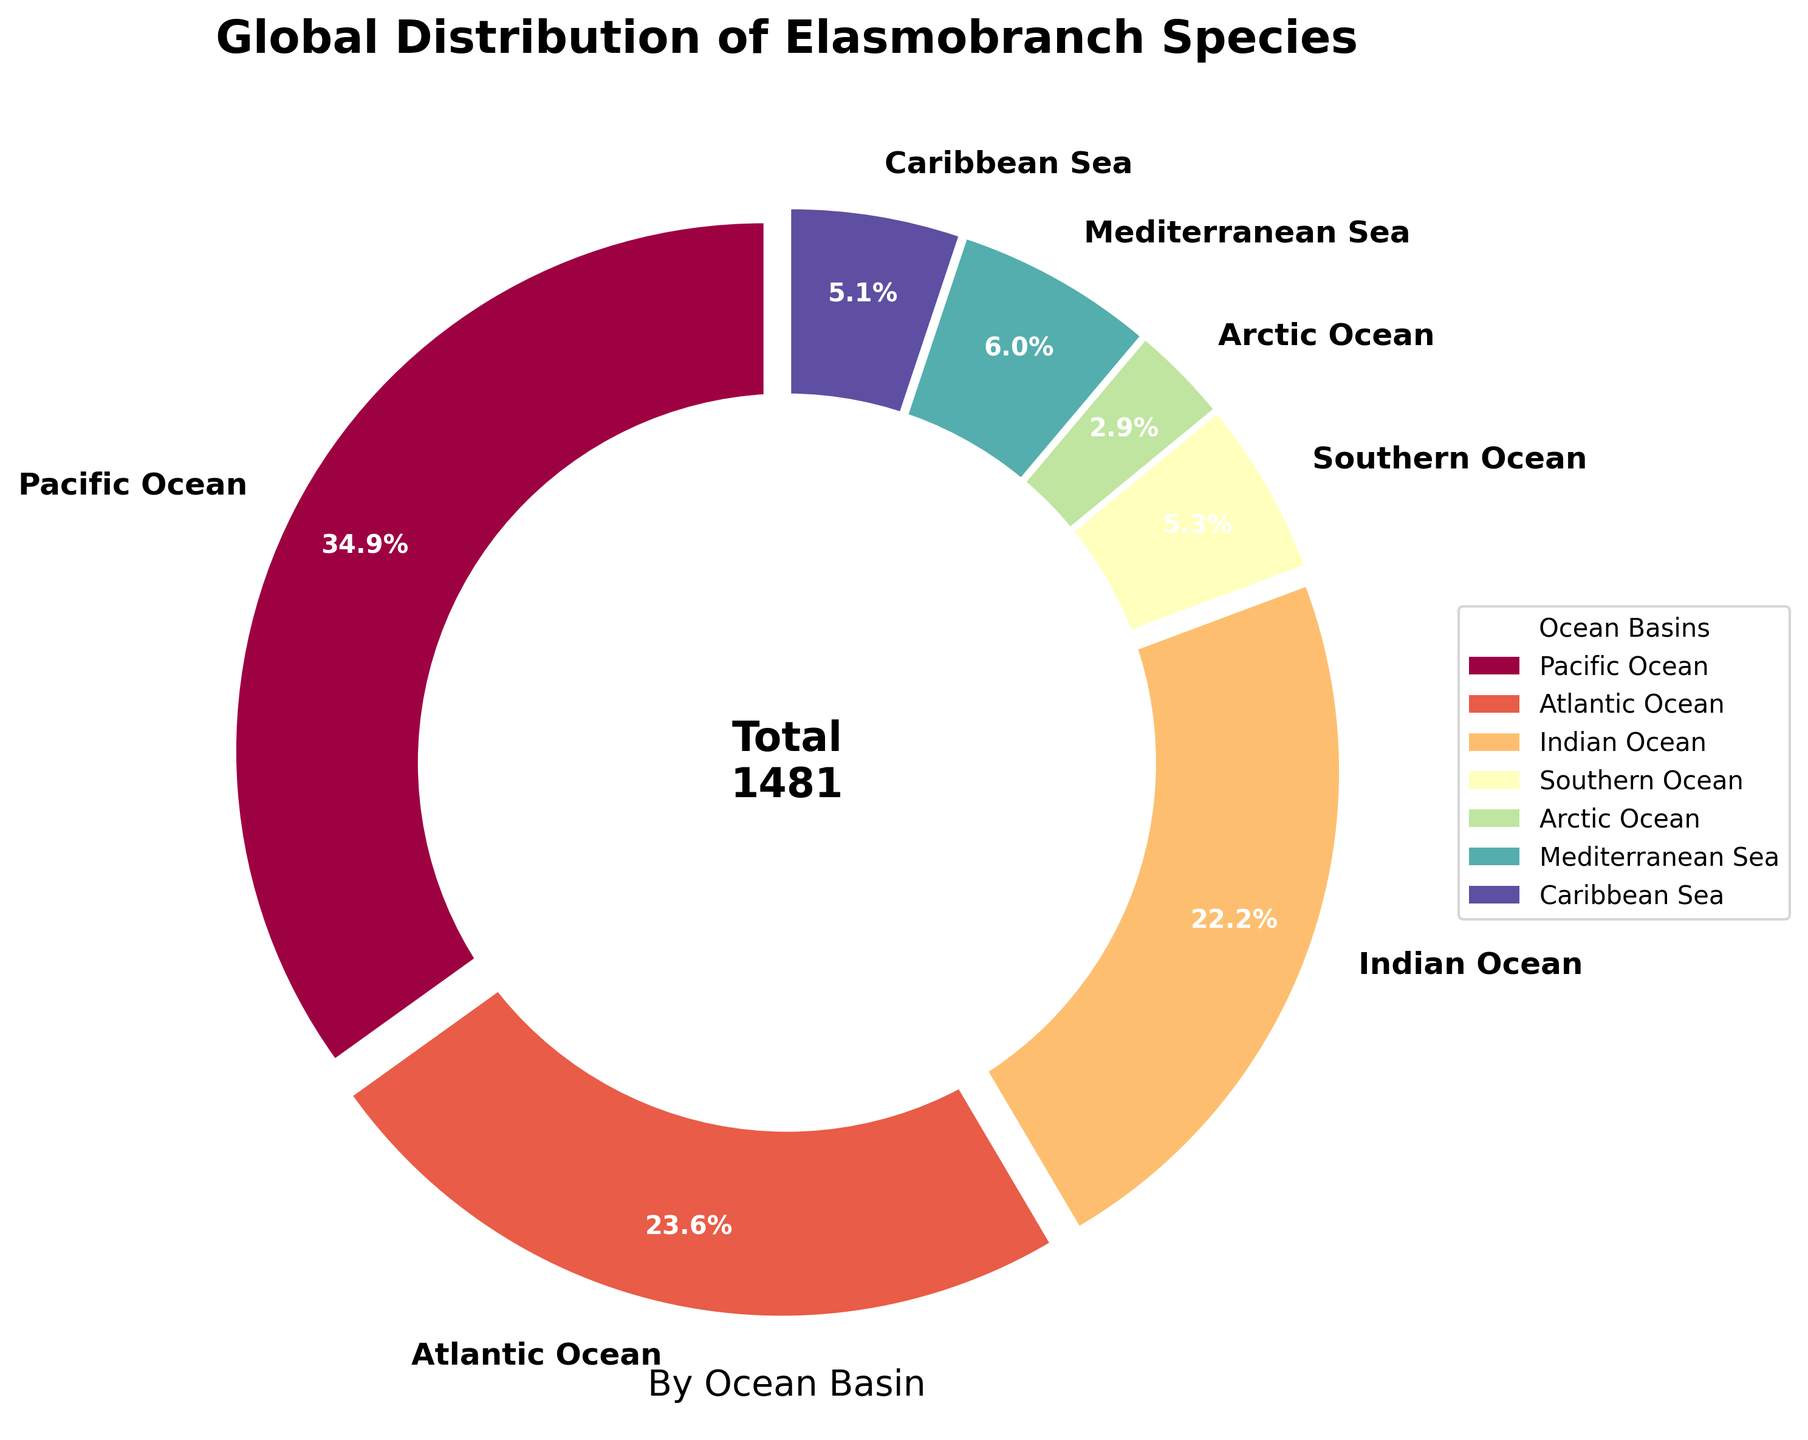What proportion of elasmobranch species are found in the Pacific Ocean? The figure indicates the portion sizes of a pie chart and includes the actual percentage for each segment. By visually identifying the segment labeled "Pacific Ocean" and reading its associated percentage, which is 41.5%, we can determine the proportion.
Answer: 41.5% Which ocean basin has the second-highest number of elasmobranch species? First, identify the ocean basin with the most elasmobranch species, which should have the largest pie chart segment. The Pacific Ocean has the most (41.5%). Next, look for the second largest segment, which corresponds to the Atlantic Ocean with 28.0%.
Answer: Atlantic Ocean How many more elasmobranch species are there in the Pacific Ocean compared to the Southern Ocean? Find the values for the Pacific Ocean (517 species) and the Southern Ocean (78 species). Subtract the number of species in the Southern Ocean from the Pacific Ocean (517 - 78 = 439).
Answer: 439 What percentage of elasmobranch species are found in the Atlantic, Indian, and Mediterranean combined? Add the number of species from the Atlantic (349), Indian (329), and Mediterranean (89) Oceans first, that is, 349 + 329 + 89 = 767. Then, find the total number of species, which is 517 + 349 + 329 + 78 + 43 + 89 + 76 = 1481. Calculate the combined percentage as (767 / 1481) * 100 = 51.8%.
Answer: 51.8% Which ocean basin has the smallest percentage of elasmobranch species, and what is this percentage? Identify the smallest segment in the pie chart, which is labeled "Arctic Ocean." Check the percentage displayed, which is 2.9%.
Answer: Arctic Ocean, 2.9% How does the number of species in the Caribbean Sea compare to the Southern Ocean? The Caribbean Sea has 76 species and the Southern Ocean has 78 species. By comparing these numbers, we see that the Caribbean Sea has slightly fewer species (76 < 78).
Answer: Southern Ocean has more species by 2 If you combine the elasmobranch species from the Arctic and Caribbean Seas, does this total surpass the Mediterranean Sea? Add the number of species from the Arctic (43) and Caribbean (76) Seas: 43 + 76 = 119. Compare this to the Mediterranean Sea, which has 89 species. Since 119 > 89, the combined total surpasses the Mediterranean Sea.
Answer: Yes What is the visual characteristic of the pie chart that indicates the Pacific Ocean segment? The visual characteristics include the size of the segment (the largest), its placement starting at the top of the chart, and its specific color within the color scheme used in the chart.
Answer: Largest segment, top placement Which three ocean basins together make up approximately half of the total elasmobranch species population? Examine the pie chart and identify the three largest segments: Pacific (41.5%), Atlantic (23.6%), and Indian (22.2%) Oceans. Together they make up approximately 41.5 + 23.6 + 22.2 = 87.3%. To get three basins that are around 50%, consider two largest segments and an additional segment that accumulates to around 50%. It's still Atlantic, Indian and another smaller basin like Mediterranean to make it around close to half (76%).
Answer: Atlantic, Indian, Mediterranean 